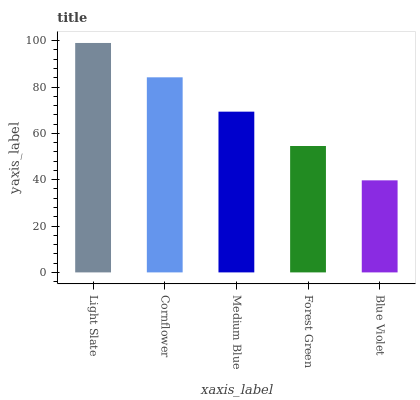Is Blue Violet the minimum?
Answer yes or no. Yes. Is Light Slate the maximum?
Answer yes or no. Yes. Is Cornflower the minimum?
Answer yes or no. No. Is Cornflower the maximum?
Answer yes or no. No. Is Light Slate greater than Cornflower?
Answer yes or no. Yes. Is Cornflower less than Light Slate?
Answer yes or no. Yes. Is Cornflower greater than Light Slate?
Answer yes or no. No. Is Light Slate less than Cornflower?
Answer yes or no. No. Is Medium Blue the high median?
Answer yes or no. Yes. Is Medium Blue the low median?
Answer yes or no. Yes. Is Blue Violet the high median?
Answer yes or no. No. Is Cornflower the low median?
Answer yes or no. No. 